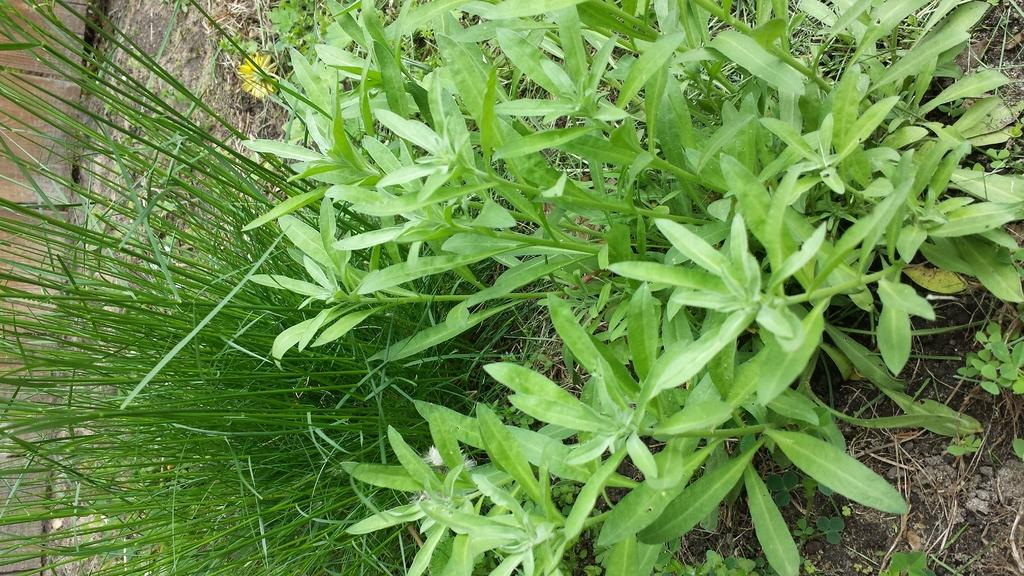What is located in the center of the image? There are plants in the center of the image. What type of vegetation can be seen in the image? There is grass visible in the image. How many minutes does the chair take to reach the next level in the image? There is no chair or level present in the image, so this question cannot be answered. 